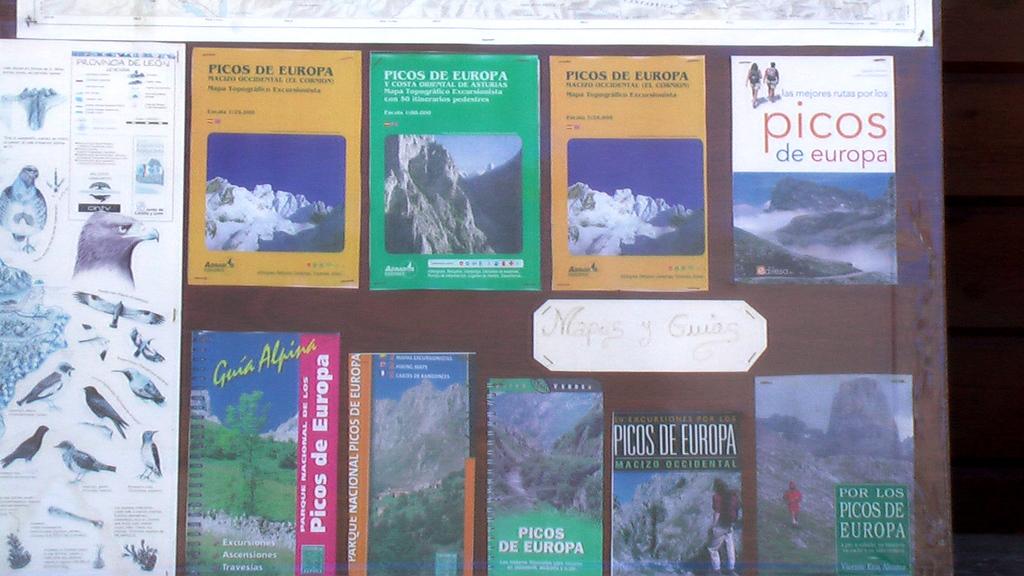What is the name of all the books?
Make the answer very short. Picos de europa. What is the name of the book on the top right?
Provide a short and direct response. Picos de europa. 